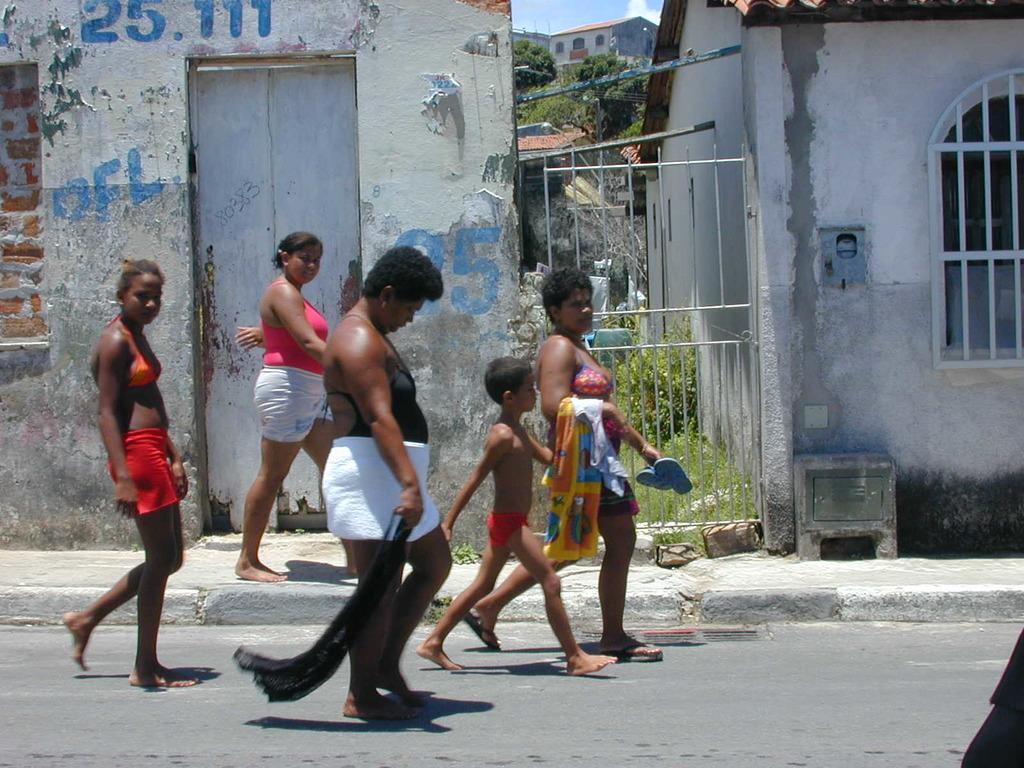In one or two sentences, can you explain what this image depicts? In this image in the center there are persons walking. In the background there are houses, trees, and there is text written on the wall of the house which is in the center. 